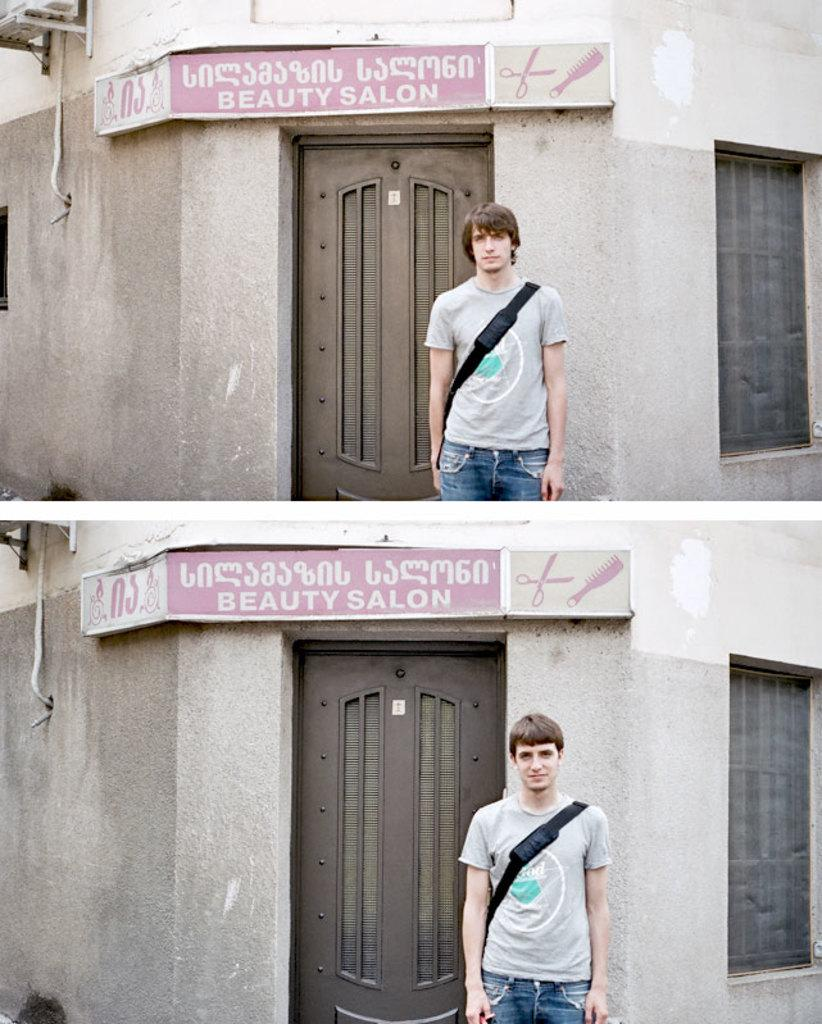What is the composition of the image? The image is a collage containing two pictures. What is the common subject in both pictures? Both pictures in the collage feature the same house. What is present in both pictures? A board is present in both pictures. Who are the people depicted in the two pictures? Different persons are depicted in each picture. What type of wrench is being used by the boys on the stage in the image? There are no boys or stage present in the image, and no wrench is being used. 